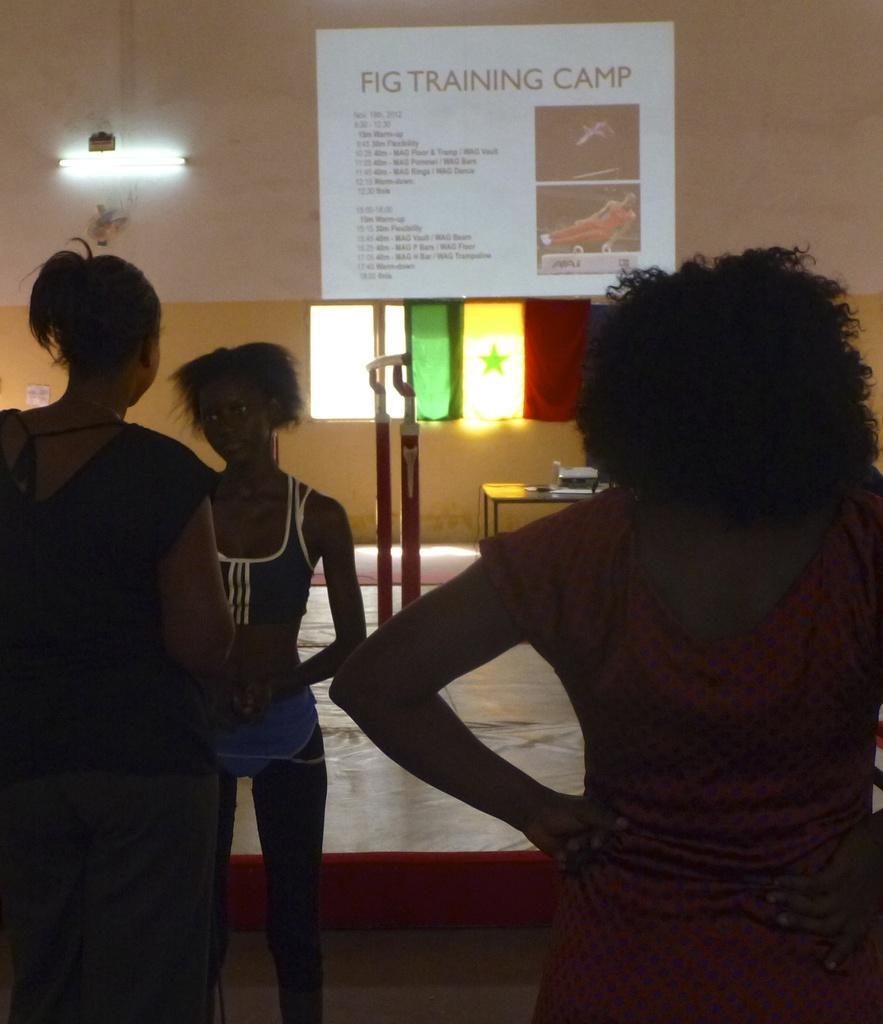How would you summarize this image in a sentence or two? Here in this picture we can see a group of women standing over a place and behind them we can see a table, on which we can see a projector present and we can see something projected on the wall and we can also see windows below that and we can see light present on the wall. 